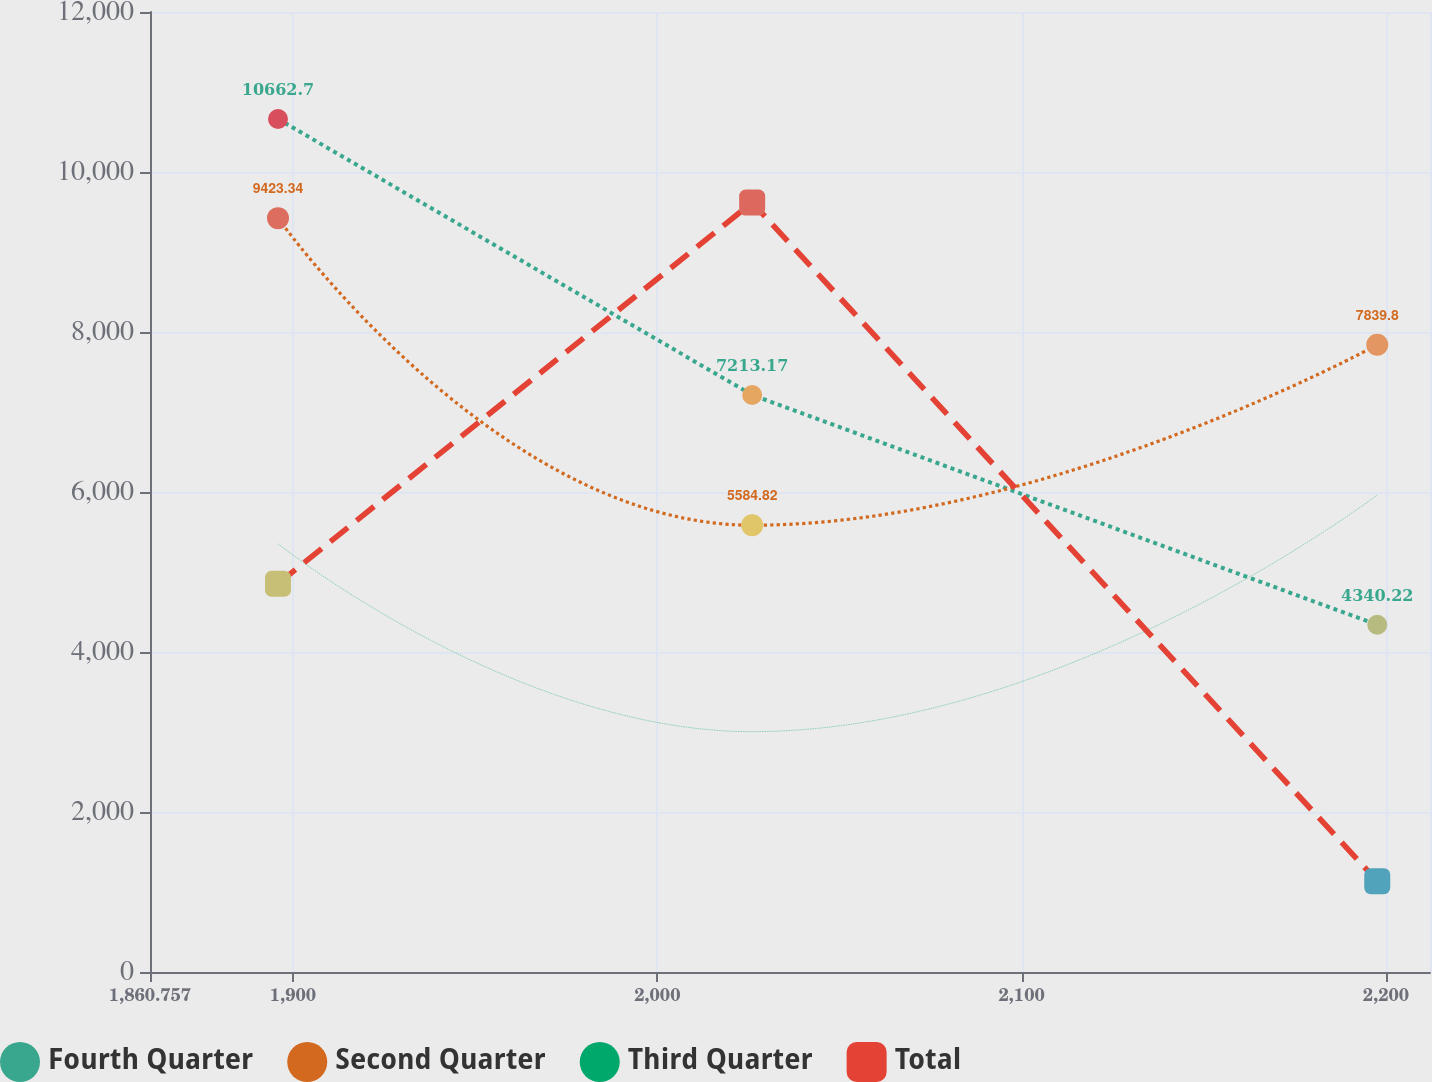<chart> <loc_0><loc_0><loc_500><loc_500><line_chart><ecel><fcel>Fourth Quarter<fcel>Second Quarter<fcel>Third Quarter<fcel>Total<nl><fcel>1895.89<fcel>10662.7<fcel>9423.34<fcel>5352.55<fcel>4853.47<nl><fcel>2026.04<fcel>7213.17<fcel>5584.82<fcel>3004.23<fcel>9618.32<nl><fcel>2197.61<fcel>4340.22<fcel>7839.8<fcel>5962.15<fcel>1135.86<nl><fcel>2247.22<fcel>2434.46<fcel>3750.81<fcel>7739.8<fcel>6784.09<nl></chart> 